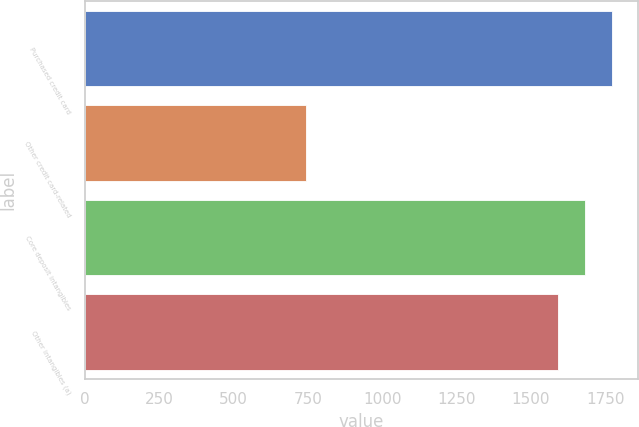<chart> <loc_0><loc_0><loc_500><loc_500><bar_chart><fcel>Purchased credit card<fcel>Other credit card-related<fcel>Core deposit intangibles<fcel>Other intangibles (a)<nl><fcel>1773.2<fcel>743<fcel>1682.6<fcel>1592<nl></chart> 